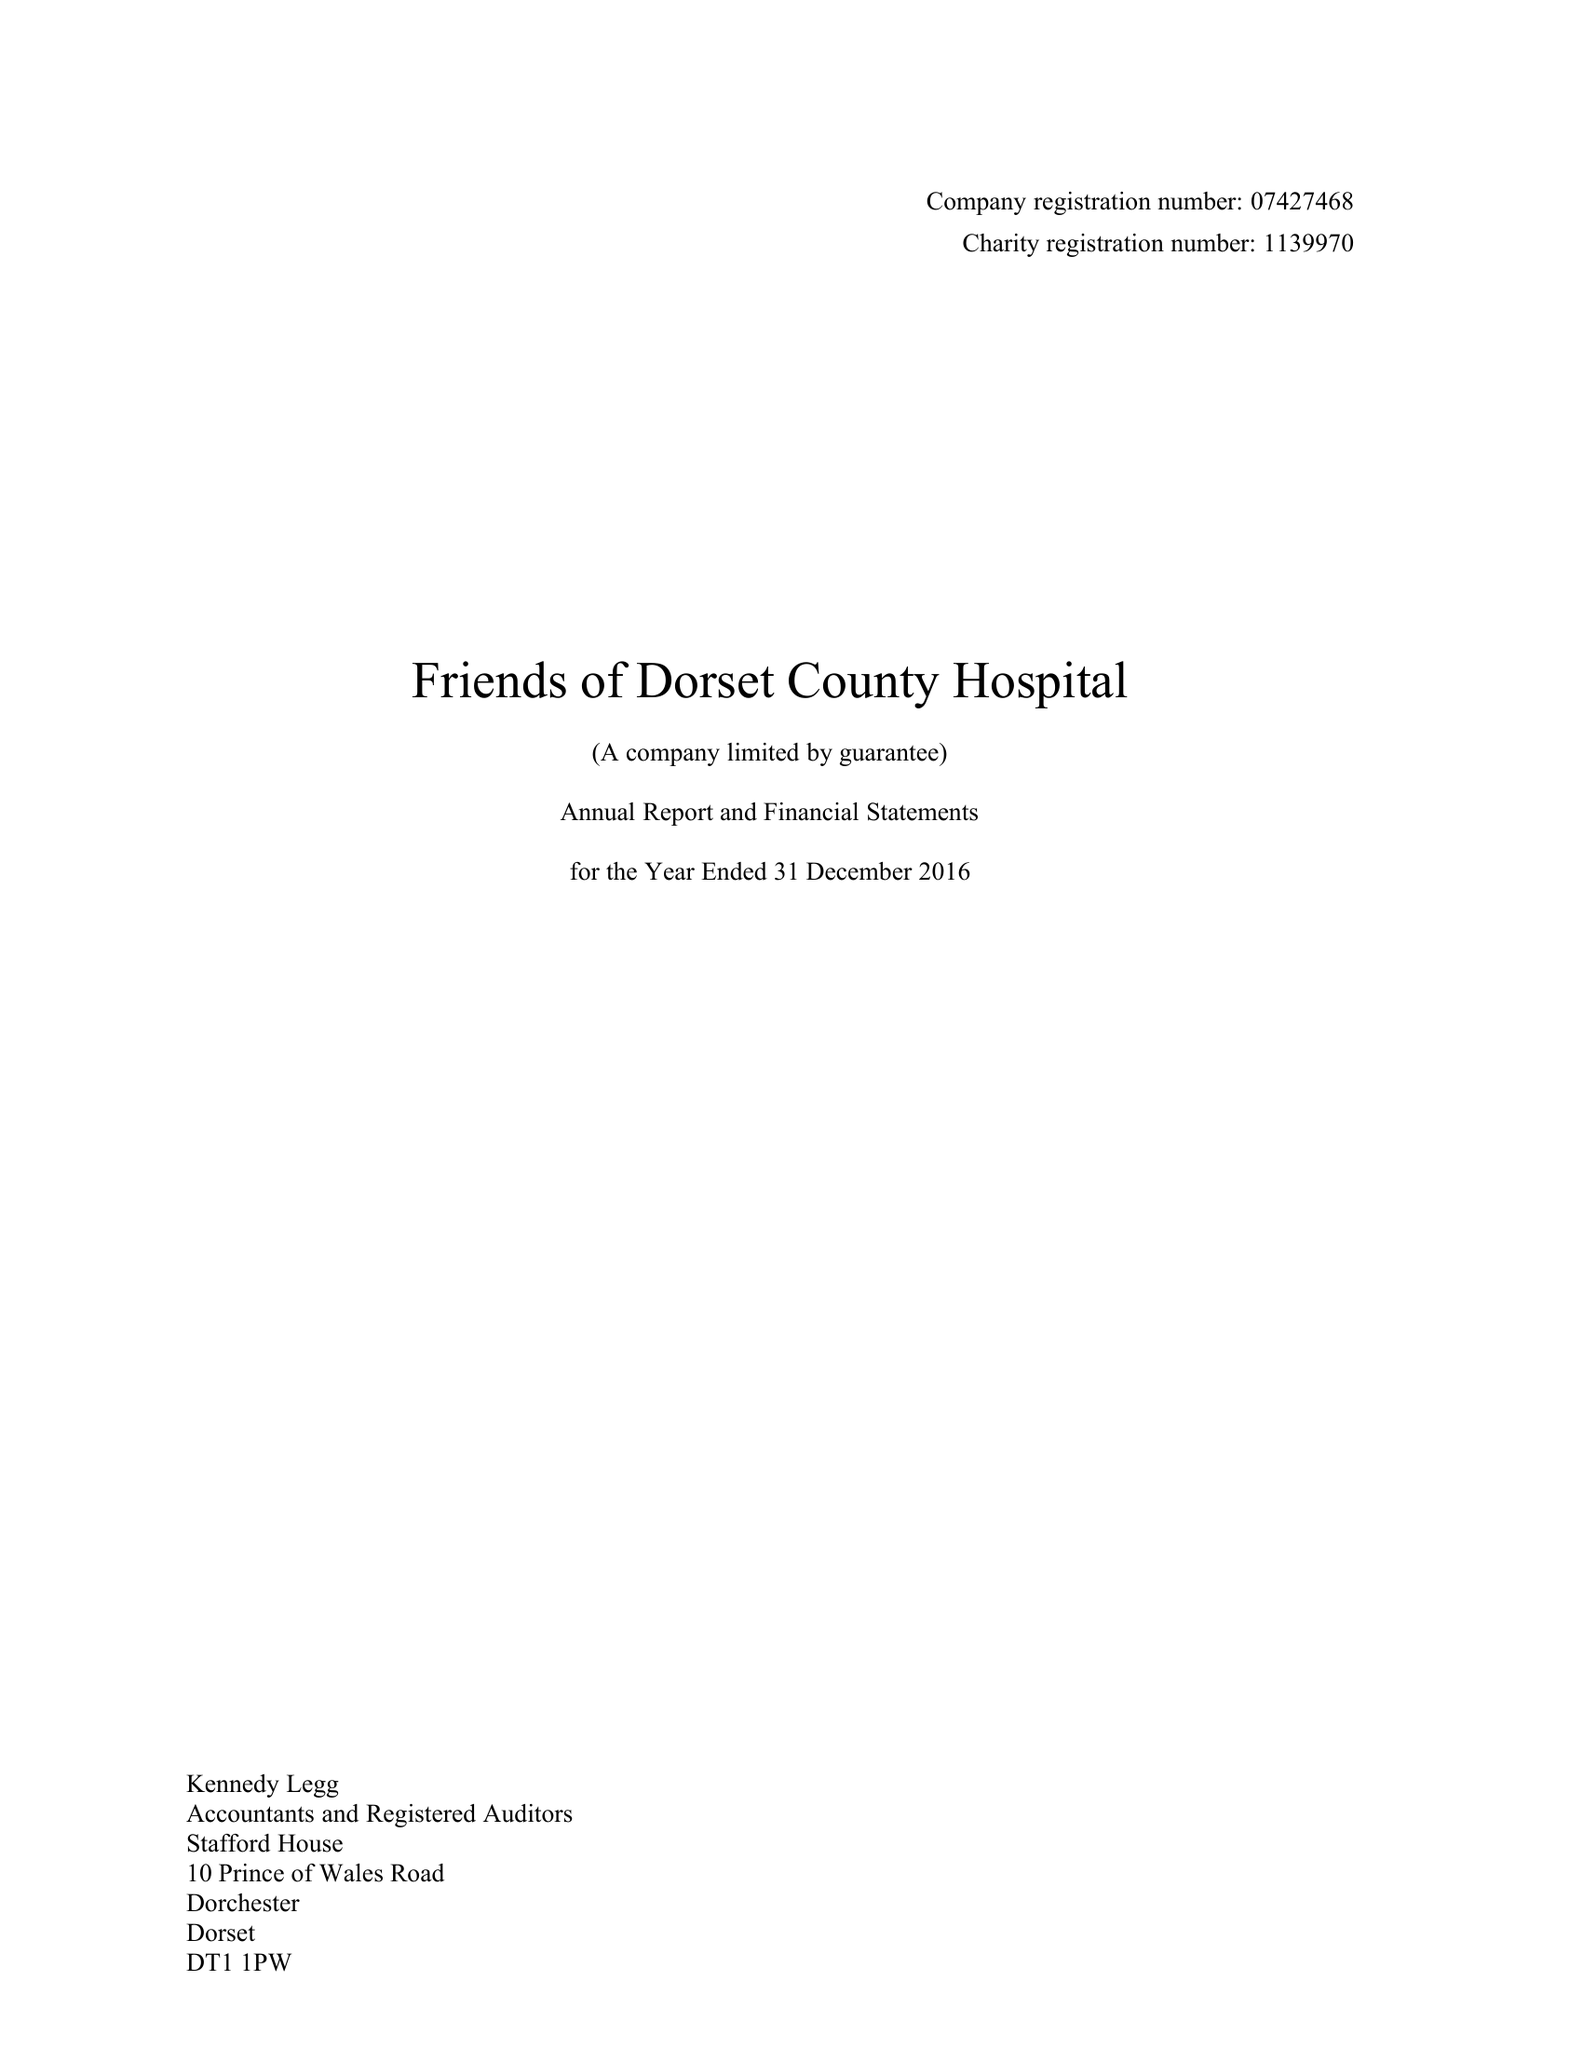What is the value for the address__street_line?
Answer the question using a single word or phrase. PRINCE OF WALES ROAD 